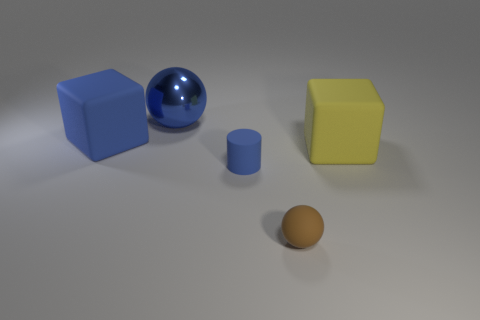Are there any other things that have the same material as the big blue ball?
Your answer should be compact. No. There is a matte block behind the big yellow block right of the blue rubber object on the right side of the big blue block; what is its size?
Make the answer very short. Large. How many other things are the same shape as the tiny blue thing?
Keep it short and to the point. 0. There is a small thing in front of the tiny rubber cylinder; is it the same shape as the large blue shiny thing that is left of the small blue cylinder?
Your answer should be very brief. Yes. What number of cylinders are brown things or tiny matte things?
Make the answer very short. 1. What material is the block right of the blue thing in front of the large rubber thing that is right of the small sphere?
Ensure brevity in your answer.  Rubber. How many other objects are the same size as the brown thing?
Offer a very short reply. 1. There is a matte object that is the same color as the rubber cylinder; what is its size?
Offer a terse response. Large. Is the number of large yellow rubber things on the right side of the brown rubber sphere greater than the number of large green cubes?
Offer a terse response. Yes. Is there a big matte thing of the same color as the rubber cylinder?
Your answer should be compact. Yes. 